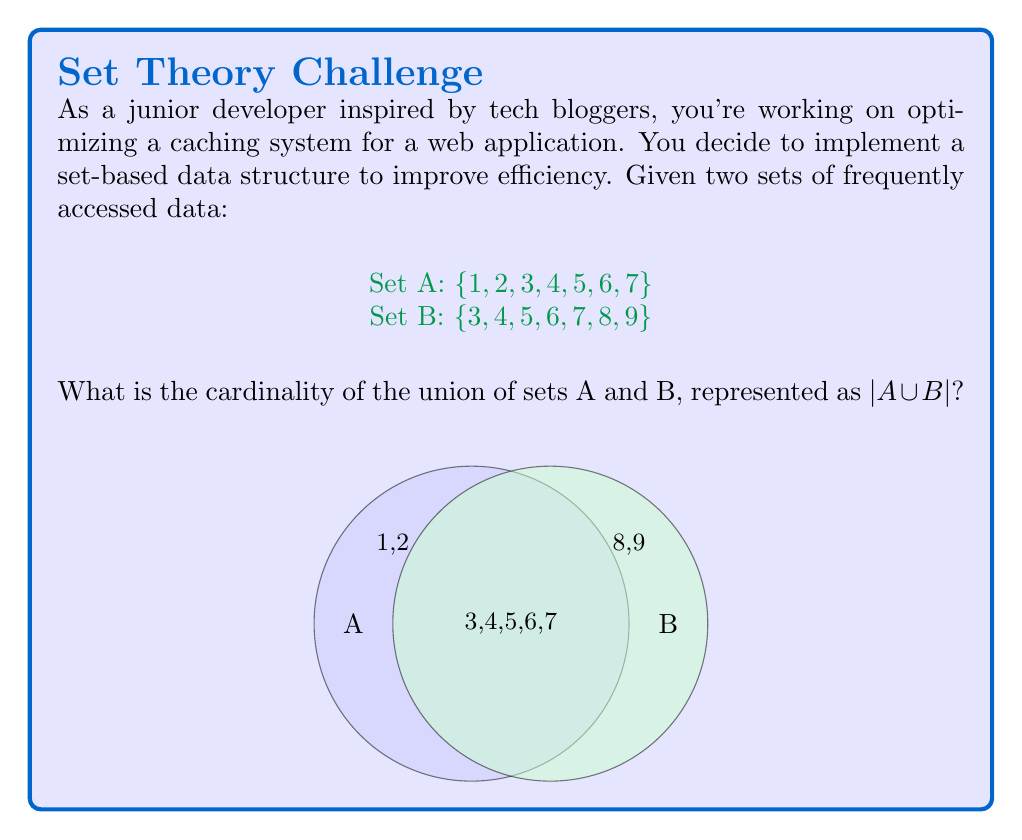Give your solution to this math problem. To find the cardinality of the union of sets A and B, we can use the principle of inclusion-exclusion:

1. First, we calculate the cardinality of each set:
   $|A| = 7$
   $|B| = 7$

2. Next, we find the intersection of A and B:
   $A \cap B = \{3, 4, 5, 6, 7\}$
   $|A \cap B| = 5$

3. The principle of inclusion-exclusion states:
   $|A \cup B| = |A| + |B| - |A \cap B|$

4. Substituting our values:
   $|A \cup B| = 7 + 7 - 5$

5. Calculating:
   $|A \cup B| = 14 - 5 = 9$

Therefore, the cardinality of the union of sets A and B is 9.
Answer: 9 